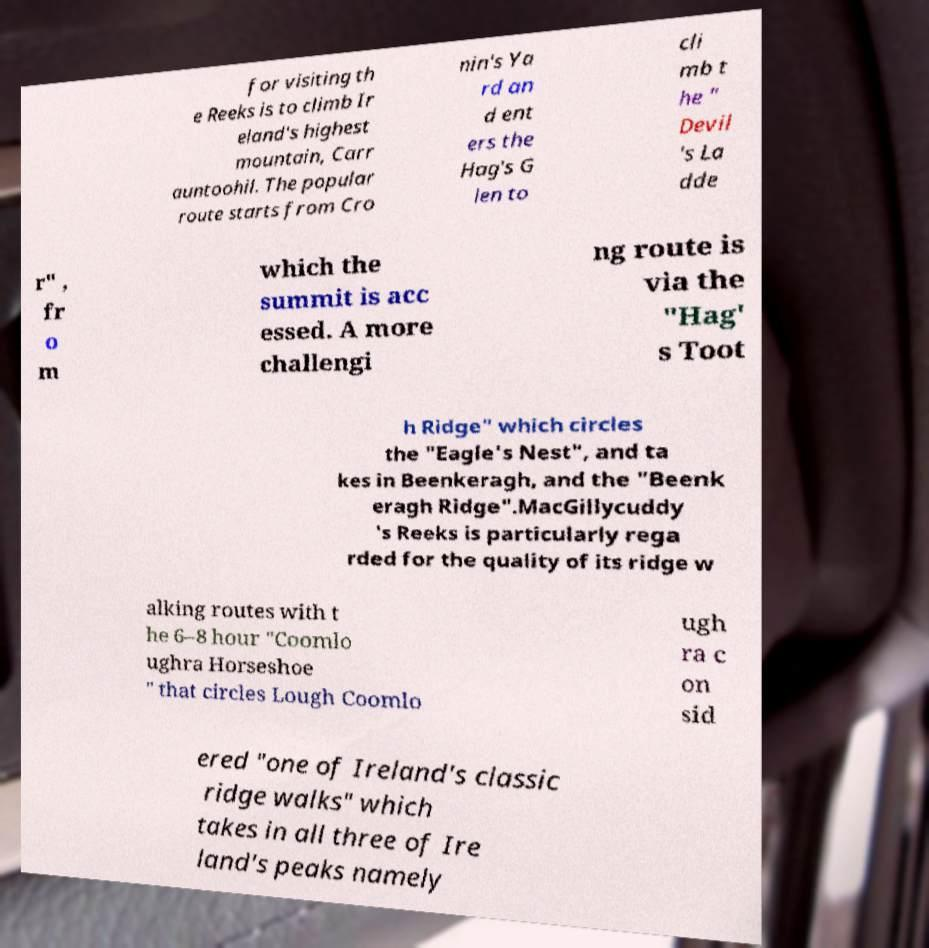Could you extract and type out the text from this image? for visiting th e Reeks is to climb Ir eland's highest mountain, Carr auntoohil. The popular route starts from Cro nin's Ya rd an d ent ers the Hag's G len to cli mb t he " Devil 's La dde r" , fr o m which the summit is acc essed. A more challengi ng route is via the "Hag' s Toot h Ridge" which circles the "Eagle's Nest", and ta kes in Beenkeragh, and the "Beenk eragh Ridge".MacGillycuddy 's Reeks is particularly rega rded for the quality of its ridge w alking routes with t he 6–8 hour "Coomlo ughra Horseshoe " that circles Lough Coomlo ugh ra c on sid ered "one of Ireland's classic ridge walks" which takes in all three of Ire land's peaks namely 